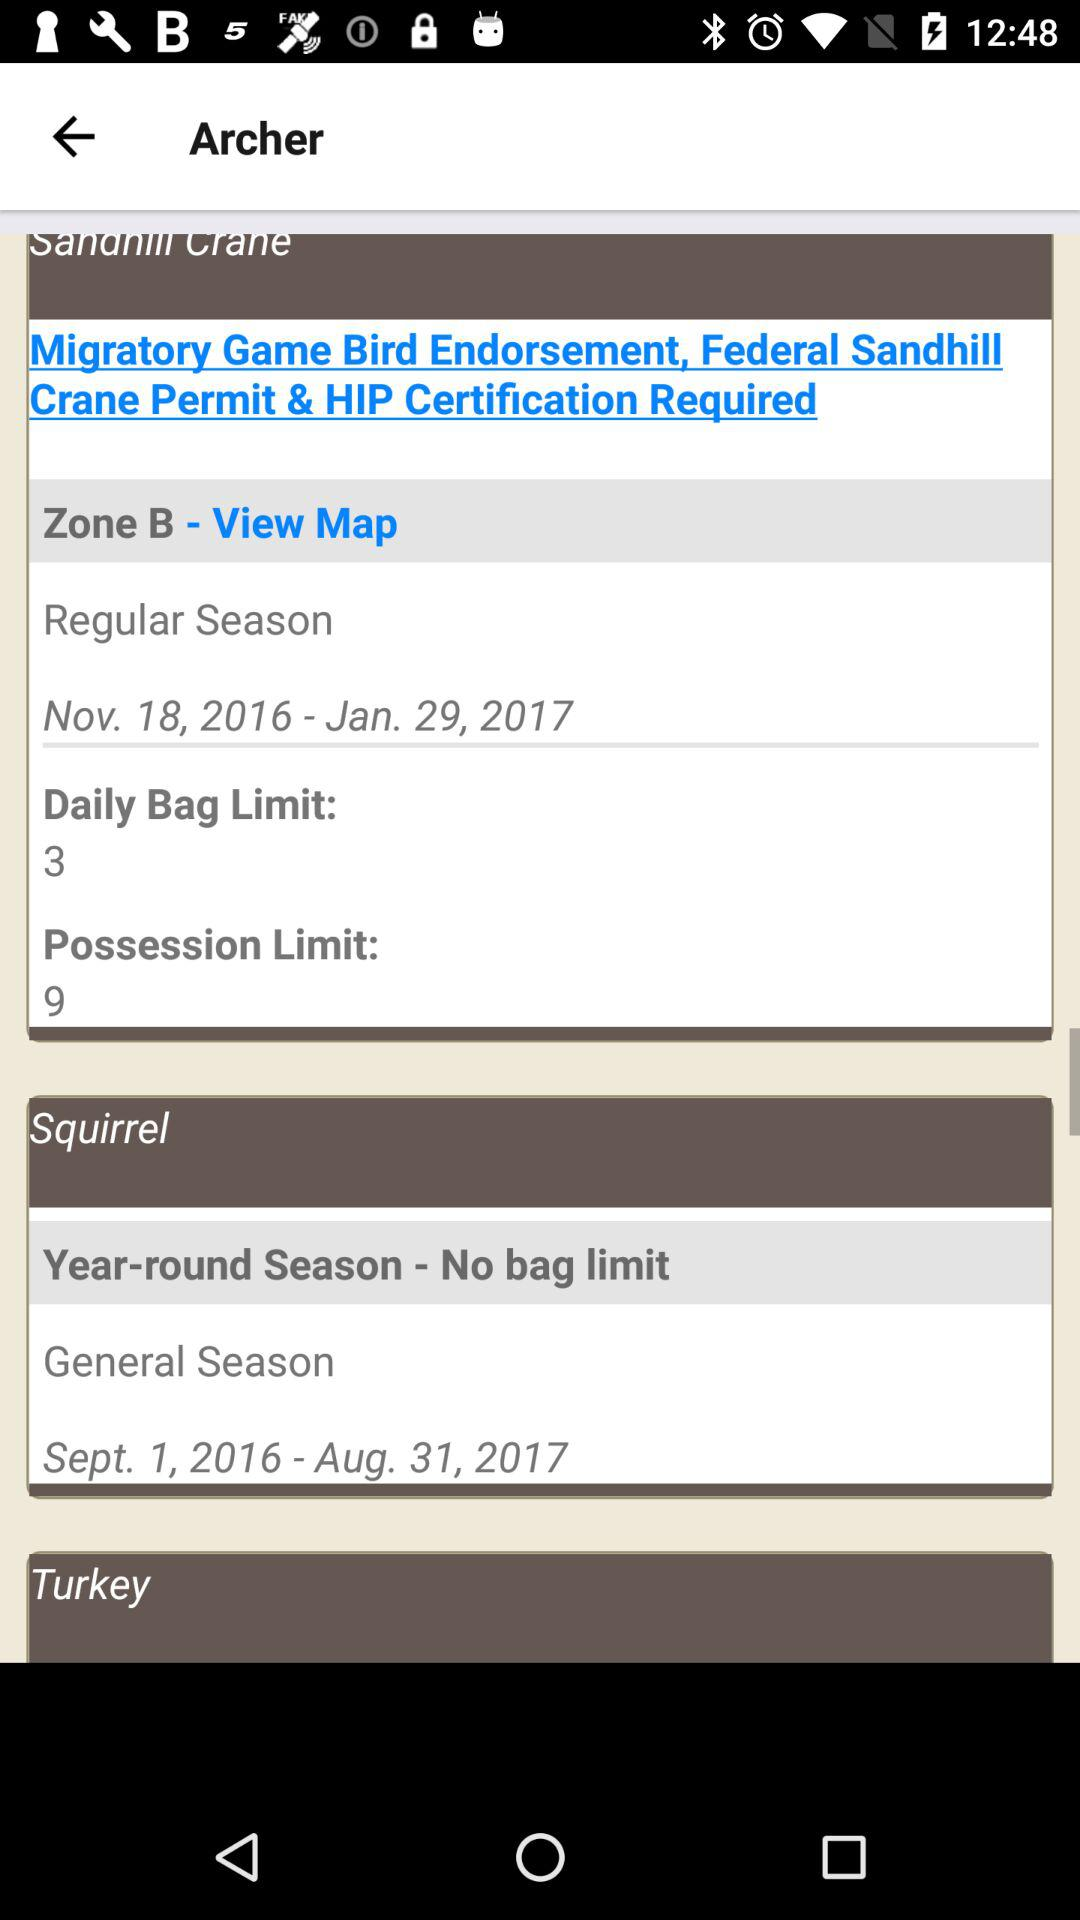What is the possession limit? The possession limit is 9. 